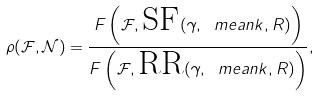Convert formula to latex. <formula><loc_0><loc_0><loc_500><loc_500>\rho ( \mathcal { F } , \mathcal { N } ) = \frac { F \left ( \mathcal { F } , \text {SF} ( \gamma , \ m e a n { k } , R ) \right ) } { F \left ( \mathcal { F } , \text {RR} ( \gamma , \ m e a n { k } , R ) \right ) } ,</formula> 